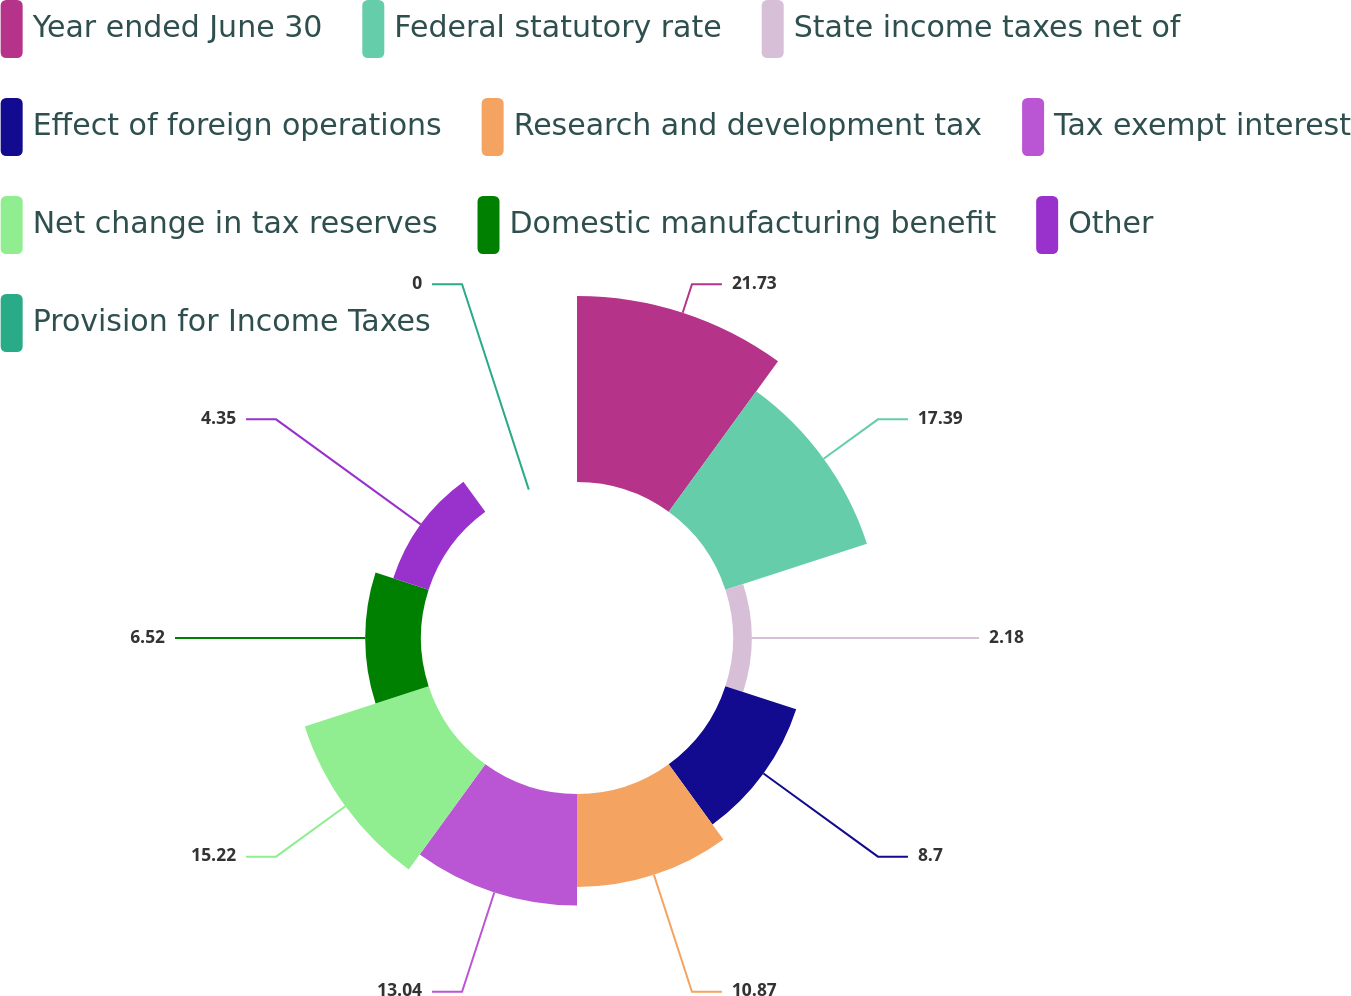<chart> <loc_0><loc_0><loc_500><loc_500><pie_chart><fcel>Year ended June 30<fcel>Federal statutory rate<fcel>State income taxes net of<fcel>Effect of foreign operations<fcel>Research and development tax<fcel>Tax exempt interest<fcel>Net change in tax reserves<fcel>Domestic manufacturing benefit<fcel>Other<fcel>Provision for Income Taxes<nl><fcel>21.73%<fcel>17.39%<fcel>2.18%<fcel>8.7%<fcel>10.87%<fcel>13.04%<fcel>15.22%<fcel>6.52%<fcel>4.35%<fcel>0.0%<nl></chart> 